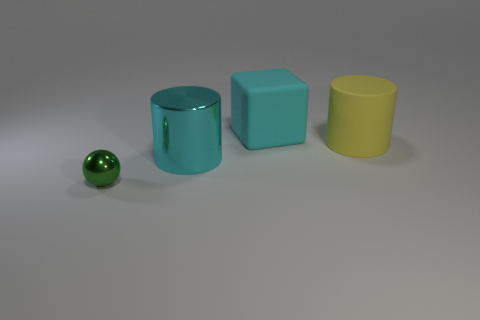Is there any other thing that has the same color as the sphere?
Make the answer very short. No. There is a shiny object on the left side of the metal object that is on the right side of the tiny green thing; are there any big yellow rubber cylinders left of it?
Provide a succinct answer. No. What is the color of the ball?
Make the answer very short. Green. Are there any green objects in front of the green thing?
Provide a short and direct response. No. Is the shape of the yellow thing the same as the shiny object that is behind the green metal object?
Ensure brevity in your answer.  Yes. How many other things are made of the same material as the yellow cylinder?
Offer a very short reply. 1. What color is the shiny thing that is on the right side of the thing that is on the left side of the metal object that is behind the small green metal thing?
Keep it short and to the point. Cyan. The large matte object that is left of the large rubber thing to the right of the cyan rubber block is what shape?
Your answer should be compact. Cube. Is the number of big yellow matte cylinders that are left of the large rubber block greater than the number of big blocks?
Provide a succinct answer. No. There is a large object on the right side of the matte cube; does it have the same shape as the large cyan matte object?
Offer a very short reply. No. 